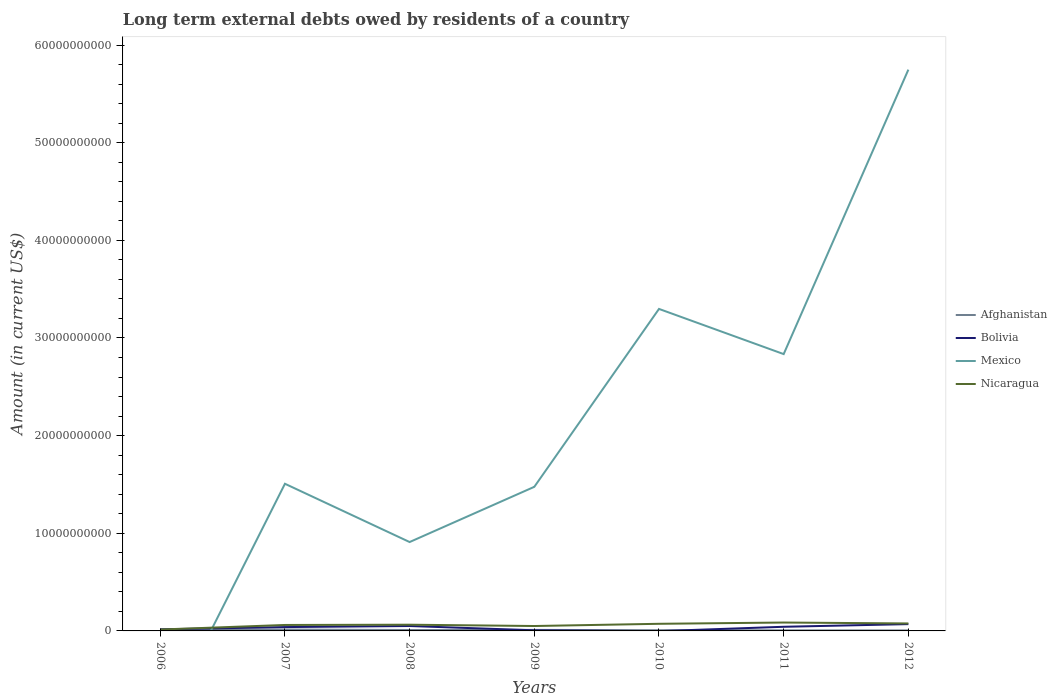Does the line corresponding to Afghanistan intersect with the line corresponding to Bolivia?
Your answer should be compact. Yes. Across all years, what is the maximum amount of long-term external debts owed by residents in Nicaragua?
Provide a short and direct response. 1.42e+08. What is the total amount of long-term external debts owed by residents in Bolivia in the graph?
Make the answer very short. -5.37e+08. What is the difference between the highest and the second highest amount of long-term external debts owed by residents in Nicaragua?
Your answer should be very brief. 7.17e+08. Is the amount of long-term external debts owed by residents in Nicaragua strictly greater than the amount of long-term external debts owed by residents in Mexico over the years?
Keep it short and to the point. No. How many lines are there?
Make the answer very short. 4. Are the values on the major ticks of Y-axis written in scientific E-notation?
Give a very brief answer. No. Does the graph contain grids?
Ensure brevity in your answer.  No. How many legend labels are there?
Provide a short and direct response. 4. What is the title of the graph?
Give a very brief answer. Long term external debts owed by residents of a country. Does "Malaysia" appear as one of the legend labels in the graph?
Your answer should be compact. No. What is the label or title of the Y-axis?
Make the answer very short. Amount (in current US$). What is the Amount (in current US$) of Afghanistan in 2006?
Your answer should be compact. 1.43e+08. What is the Amount (in current US$) of Bolivia in 2006?
Make the answer very short. 1.61e+08. What is the Amount (in current US$) of Nicaragua in 2006?
Give a very brief answer. 1.42e+08. What is the Amount (in current US$) in Afghanistan in 2007?
Keep it short and to the point. 1.46e+08. What is the Amount (in current US$) of Bolivia in 2007?
Ensure brevity in your answer.  3.93e+08. What is the Amount (in current US$) in Mexico in 2007?
Your answer should be compact. 1.51e+1. What is the Amount (in current US$) in Nicaragua in 2007?
Your answer should be compact. 6.09e+08. What is the Amount (in current US$) of Afghanistan in 2008?
Provide a succinct answer. 9.51e+07. What is the Amount (in current US$) in Bolivia in 2008?
Your answer should be very brief. 5.02e+08. What is the Amount (in current US$) of Mexico in 2008?
Provide a succinct answer. 9.10e+09. What is the Amount (in current US$) of Nicaragua in 2008?
Ensure brevity in your answer.  6.36e+08. What is the Amount (in current US$) of Afghanistan in 2009?
Your answer should be very brief. 1.06e+08. What is the Amount (in current US$) in Bolivia in 2009?
Offer a very short reply. 6.47e+07. What is the Amount (in current US$) in Mexico in 2009?
Make the answer very short. 1.48e+1. What is the Amount (in current US$) in Nicaragua in 2009?
Ensure brevity in your answer.  5.03e+08. What is the Amount (in current US$) of Afghanistan in 2010?
Provide a succinct answer. 7.50e+07. What is the Amount (in current US$) in Mexico in 2010?
Your response must be concise. 3.30e+1. What is the Amount (in current US$) in Nicaragua in 2010?
Make the answer very short. 7.29e+08. What is the Amount (in current US$) of Afghanistan in 2011?
Offer a terse response. 6.14e+07. What is the Amount (in current US$) of Bolivia in 2011?
Offer a very short reply. 4.25e+08. What is the Amount (in current US$) in Mexico in 2011?
Offer a terse response. 2.83e+1. What is the Amount (in current US$) in Nicaragua in 2011?
Provide a succinct answer. 8.59e+08. What is the Amount (in current US$) of Afghanistan in 2012?
Ensure brevity in your answer.  5.12e+07. What is the Amount (in current US$) in Bolivia in 2012?
Keep it short and to the point. 6.98e+08. What is the Amount (in current US$) of Mexico in 2012?
Keep it short and to the point. 5.75e+1. What is the Amount (in current US$) of Nicaragua in 2012?
Your answer should be very brief. 7.65e+08. Across all years, what is the maximum Amount (in current US$) in Afghanistan?
Make the answer very short. 1.46e+08. Across all years, what is the maximum Amount (in current US$) in Bolivia?
Keep it short and to the point. 6.98e+08. Across all years, what is the maximum Amount (in current US$) in Mexico?
Provide a short and direct response. 5.75e+1. Across all years, what is the maximum Amount (in current US$) of Nicaragua?
Provide a succinct answer. 8.59e+08. Across all years, what is the minimum Amount (in current US$) in Afghanistan?
Offer a very short reply. 5.12e+07. Across all years, what is the minimum Amount (in current US$) of Bolivia?
Offer a terse response. 0. Across all years, what is the minimum Amount (in current US$) in Nicaragua?
Provide a short and direct response. 1.42e+08. What is the total Amount (in current US$) of Afghanistan in the graph?
Give a very brief answer. 6.77e+08. What is the total Amount (in current US$) of Bolivia in the graph?
Provide a succinct answer. 2.24e+09. What is the total Amount (in current US$) of Mexico in the graph?
Provide a succinct answer. 1.58e+11. What is the total Amount (in current US$) of Nicaragua in the graph?
Your answer should be very brief. 4.24e+09. What is the difference between the Amount (in current US$) in Afghanistan in 2006 and that in 2007?
Provide a succinct answer. -2.77e+06. What is the difference between the Amount (in current US$) of Bolivia in 2006 and that in 2007?
Provide a short and direct response. -2.32e+08. What is the difference between the Amount (in current US$) of Nicaragua in 2006 and that in 2007?
Offer a very short reply. -4.67e+08. What is the difference between the Amount (in current US$) in Afghanistan in 2006 and that in 2008?
Provide a succinct answer. 4.78e+07. What is the difference between the Amount (in current US$) of Bolivia in 2006 and that in 2008?
Your answer should be compact. -3.41e+08. What is the difference between the Amount (in current US$) of Nicaragua in 2006 and that in 2008?
Keep it short and to the point. -4.95e+08. What is the difference between the Amount (in current US$) in Afghanistan in 2006 and that in 2009?
Offer a very short reply. 3.73e+07. What is the difference between the Amount (in current US$) of Bolivia in 2006 and that in 2009?
Provide a succinct answer. 9.64e+07. What is the difference between the Amount (in current US$) in Nicaragua in 2006 and that in 2009?
Your answer should be compact. -3.61e+08. What is the difference between the Amount (in current US$) of Afghanistan in 2006 and that in 2010?
Ensure brevity in your answer.  6.79e+07. What is the difference between the Amount (in current US$) of Nicaragua in 2006 and that in 2010?
Ensure brevity in your answer.  -5.88e+08. What is the difference between the Amount (in current US$) in Afghanistan in 2006 and that in 2011?
Offer a terse response. 8.16e+07. What is the difference between the Amount (in current US$) of Bolivia in 2006 and that in 2011?
Your response must be concise. -2.63e+08. What is the difference between the Amount (in current US$) in Nicaragua in 2006 and that in 2011?
Your answer should be very brief. -7.17e+08. What is the difference between the Amount (in current US$) in Afghanistan in 2006 and that in 2012?
Your answer should be very brief. 9.18e+07. What is the difference between the Amount (in current US$) of Bolivia in 2006 and that in 2012?
Your response must be concise. -5.37e+08. What is the difference between the Amount (in current US$) in Nicaragua in 2006 and that in 2012?
Offer a terse response. -6.23e+08. What is the difference between the Amount (in current US$) in Afghanistan in 2007 and that in 2008?
Offer a terse response. 5.06e+07. What is the difference between the Amount (in current US$) in Bolivia in 2007 and that in 2008?
Provide a succinct answer. -1.09e+08. What is the difference between the Amount (in current US$) of Mexico in 2007 and that in 2008?
Your answer should be very brief. 5.97e+09. What is the difference between the Amount (in current US$) of Nicaragua in 2007 and that in 2008?
Your answer should be compact. -2.75e+07. What is the difference between the Amount (in current US$) in Afghanistan in 2007 and that in 2009?
Provide a succinct answer. 4.01e+07. What is the difference between the Amount (in current US$) in Bolivia in 2007 and that in 2009?
Your answer should be compact. 3.28e+08. What is the difference between the Amount (in current US$) of Mexico in 2007 and that in 2009?
Ensure brevity in your answer.  3.13e+08. What is the difference between the Amount (in current US$) in Nicaragua in 2007 and that in 2009?
Offer a terse response. 1.06e+08. What is the difference between the Amount (in current US$) in Afghanistan in 2007 and that in 2010?
Your answer should be very brief. 7.07e+07. What is the difference between the Amount (in current US$) in Mexico in 2007 and that in 2010?
Give a very brief answer. -1.79e+1. What is the difference between the Amount (in current US$) of Nicaragua in 2007 and that in 2010?
Give a very brief answer. -1.21e+08. What is the difference between the Amount (in current US$) of Afghanistan in 2007 and that in 2011?
Give a very brief answer. 8.43e+07. What is the difference between the Amount (in current US$) of Bolivia in 2007 and that in 2011?
Keep it short and to the point. -3.15e+07. What is the difference between the Amount (in current US$) of Mexico in 2007 and that in 2011?
Your answer should be compact. -1.33e+1. What is the difference between the Amount (in current US$) of Nicaragua in 2007 and that in 2011?
Provide a short and direct response. -2.50e+08. What is the difference between the Amount (in current US$) of Afghanistan in 2007 and that in 2012?
Your answer should be compact. 9.45e+07. What is the difference between the Amount (in current US$) of Bolivia in 2007 and that in 2012?
Offer a very short reply. -3.05e+08. What is the difference between the Amount (in current US$) in Mexico in 2007 and that in 2012?
Give a very brief answer. -4.24e+1. What is the difference between the Amount (in current US$) of Nicaragua in 2007 and that in 2012?
Make the answer very short. -1.56e+08. What is the difference between the Amount (in current US$) in Afghanistan in 2008 and that in 2009?
Ensure brevity in your answer.  -1.05e+07. What is the difference between the Amount (in current US$) in Bolivia in 2008 and that in 2009?
Your answer should be very brief. 4.38e+08. What is the difference between the Amount (in current US$) in Mexico in 2008 and that in 2009?
Your answer should be very brief. -5.65e+09. What is the difference between the Amount (in current US$) in Nicaragua in 2008 and that in 2009?
Provide a short and direct response. 1.34e+08. What is the difference between the Amount (in current US$) in Afghanistan in 2008 and that in 2010?
Keep it short and to the point. 2.01e+07. What is the difference between the Amount (in current US$) of Mexico in 2008 and that in 2010?
Your answer should be compact. -2.39e+1. What is the difference between the Amount (in current US$) of Nicaragua in 2008 and that in 2010?
Give a very brief answer. -9.31e+07. What is the difference between the Amount (in current US$) of Afghanistan in 2008 and that in 2011?
Give a very brief answer. 3.37e+07. What is the difference between the Amount (in current US$) in Bolivia in 2008 and that in 2011?
Your response must be concise. 7.78e+07. What is the difference between the Amount (in current US$) of Mexico in 2008 and that in 2011?
Your answer should be compact. -1.92e+1. What is the difference between the Amount (in current US$) in Nicaragua in 2008 and that in 2011?
Keep it short and to the point. -2.22e+08. What is the difference between the Amount (in current US$) in Afghanistan in 2008 and that in 2012?
Your answer should be compact. 4.39e+07. What is the difference between the Amount (in current US$) of Bolivia in 2008 and that in 2012?
Provide a short and direct response. -1.96e+08. What is the difference between the Amount (in current US$) in Mexico in 2008 and that in 2012?
Make the answer very short. -4.84e+1. What is the difference between the Amount (in current US$) in Nicaragua in 2008 and that in 2012?
Your response must be concise. -1.29e+08. What is the difference between the Amount (in current US$) in Afghanistan in 2009 and that in 2010?
Your response must be concise. 3.06e+07. What is the difference between the Amount (in current US$) of Mexico in 2009 and that in 2010?
Ensure brevity in your answer.  -1.82e+1. What is the difference between the Amount (in current US$) in Nicaragua in 2009 and that in 2010?
Keep it short and to the point. -2.27e+08. What is the difference between the Amount (in current US$) in Afghanistan in 2009 and that in 2011?
Give a very brief answer. 4.43e+07. What is the difference between the Amount (in current US$) of Bolivia in 2009 and that in 2011?
Keep it short and to the point. -3.60e+08. What is the difference between the Amount (in current US$) in Mexico in 2009 and that in 2011?
Make the answer very short. -1.36e+1. What is the difference between the Amount (in current US$) in Nicaragua in 2009 and that in 2011?
Ensure brevity in your answer.  -3.56e+08. What is the difference between the Amount (in current US$) of Afghanistan in 2009 and that in 2012?
Provide a short and direct response. 5.45e+07. What is the difference between the Amount (in current US$) in Bolivia in 2009 and that in 2012?
Your answer should be very brief. -6.34e+08. What is the difference between the Amount (in current US$) in Mexico in 2009 and that in 2012?
Offer a very short reply. -4.27e+1. What is the difference between the Amount (in current US$) of Nicaragua in 2009 and that in 2012?
Provide a succinct answer. -2.62e+08. What is the difference between the Amount (in current US$) of Afghanistan in 2010 and that in 2011?
Provide a short and direct response. 1.37e+07. What is the difference between the Amount (in current US$) in Mexico in 2010 and that in 2011?
Give a very brief answer. 4.63e+09. What is the difference between the Amount (in current US$) of Nicaragua in 2010 and that in 2011?
Provide a short and direct response. -1.29e+08. What is the difference between the Amount (in current US$) in Afghanistan in 2010 and that in 2012?
Provide a succinct answer. 2.39e+07. What is the difference between the Amount (in current US$) in Mexico in 2010 and that in 2012?
Give a very brief answer. -2.45e+1. What is the difference between the Amount (in current US$) in Nicaragua in 2010 and that in 2012?
Your answer should be very brief. -3.56e+07. What is the difference between the Amount (in current US$) in Afghanistan in 2011 and that in 2012?
Make the answer very short. 1.02e+07. What is the difference between the Amount (in current US$) in Bolivia in 2011 and that in 2012?
Ensure brevity in your answer.  -2.74e+08. What is the difference between the Amount (in current US$) in Mexico in 2011 and that in 2012?
Your answer should be compact. -2.91e+1. What is the difference between the Amount (in current US$) in Nicaragua in 2011 and that in 2012?
Your answer should be very brief. 9.35e+07. What is the difference between the Amount (in current US$) of Afghanistan in 2006 and the Amount (in current US$) of Bolivia in 2007?
Make the answer very short. -2.50e+08. What is the difference between the Amount (in current US$) in Afghanistan in 2006 and the Amount (in current US$) in Mexico in 2007?
Your answer should be compact. -1.49e+1. What is the difference between the Amount (in current US$) in Afghanistan in 2006 and the Amount (in current US$) in Nicaragua in 2007?
Your answer should be very brief. -4.66e+08. What is the difference between the Amount (in current US$) in Bolivia in 2006 and the Amount (in current US$) in Mexico in 2007?
Give a very brief answer. -1.49e+1. What is the difference between the Amount (in current US$) in Bolivia in 2006 and the Amount (in current US$) in Nicaragua in 2007?
Offer a very short reply. -4.48e+08. What is the difference between the Amount (in current US$) in Afghanistan in 2006 and the Amount (in current US$) in Bolivia in 2008?
Your answer should be compact. -3.59e+08. What is the difference between the Amount (in current US$) of Afghanistan in 2006 and the Amount (in current US$) of Mexico in 2008?
Give a very brief answer. -8.96e+09. What is the difference between the Amount (in current US$) of Afghanistan in 2006 and the Amount (in current US$) of Nicaragua in 2008?
Provide a short and direct response. -4.93e+08. What is the difference between the Amount (in current US$) in Bolivia in 2006 and the Amount (in current US$) in Mexico in 2008?
Provide a succinct answer. -8.94e+09. What is the difference between the Amount (in current US$) of Bolivia in 2006 and the Amount (in current US$) of Nicaragua in 2008?
Your answer should be very brief. -4.75e+08. What is the difference between the Amount (in current US$) of Afghanistan in 2006 and the Amount (in current US$) of Bolivia in 2009?
Make the answer very short. 7.83e+07. What is the difference between the Amount (in current US$) in Afghanistan in 2006 and the Amount (in current US$) in Mexico in 2009?
Give a very brief answer. -1.46e+1. What is the difference between the Amount (in current US$) of Afghanistan in 2006 and the Amount (in current US$) of Nicaragua in 2009?
Give a very brief answer. -3.60e+08. What is the difference between the Amount (in current US$) in Bolivia in 2006 and the Amount (in current US$) in Mexico in 2009?
Your answer should be compact. -1.46e+1. What is the difference between the Amount (in current US$) in Bolivia in 2006 and the Amount (in current US$) in Nicaragua in 2009?
Give a very brief answer. -3.42e+08. What is the difference between the Amount (in current US$) of Afghanistan in 2006 and the Amount (in current US$) of Mexico in 2010?
Your answer should be very brief. -3.28e+1. What is the difference between the Amount (in current US$) in Afghanistan in 2006 and the Amount (in current US$) in Nicaragua in 2010?
Your answer should be very brief. -5.86e+08. What is the difference between the Amount (in current US$) of Bolivia in 2006 and the Amount (in current US$) of Mexico in 2010?
Keep it short and to the point. -3.28e+1. What is the difference between the Amount (in current US$) in Bolivia in 2006 and the Amount (in current US$) in Nicaragua in 2010?
Give a very brief answer. -5.68e+08. What is the difference between the Amount (in current US$) of Afghanistan in 2006 and the Amount (in current US$) of Bolivia in 2011?
Your answer should be compact. -2.82e+08. What is the difference between the Amount (in current US$) in Afghanistan in 2006 and the Amount (in current US$) in Mexico in 2011?
Give a very brief answer. -2.82e+1. What is the difference between the Amount (in current US$) in Afghanistan in 2006 and the Amount (in current US$) in Nicaragua in 2011?
Your response must be concise. -7.16e+08. What is the difference between the Amount (in current US$) of Bolivia in 2006 and the Amount (in current US$) of Mexico in 2011?
Your response must be concise. -2.82e+1. What is the difference between the Amount (in current US$) of Bolivia in 2006 and the Amount (in current US$) of Nicaragua in 2011?
Provide a succinct answer. -6.97e+08. What is the difference between the Amount (in current US$) of Afghanistan in 2006 and the Amount (in current US$) of Bolivia in 2012?
Your answer should be very brief. -5.55e+08. What is the difference between the Amount (in current US$) in Afghanistan in 2006 and the Amount (in current US$) in Mexico in 2012?
Make the answer very short. -5.73e+1. What is the difference between the Amount (in current US$) of Afghanistan in 2006 and the Amount (in current US$) of Nicaragua in 2012?
Provide a short and direct response. -6.22e+08. What is the difference between the Amount (in current US$) of Bolivia in 2006 and the Amount (in current US$) of Mexico in 2012?
Make the answer very short. -5.73e+1. What is the difference between the Amount (in current US$) in Bolivia in 2006 and the Amount (in current US$) in Nicaragua in 2012?
Provide a succinct answer. -6.04e+08. What is the difference between the Amount (in current US$) of Afghanistan in 2007 and the Amount (in current US$) of Bolivia in 2008?
Provide a short and direct response. -3.57e+08. What is the difference between the Amount (in current US$) in Afghanistan in 2007 and the Amount (in current US$) in Mexico in 2008?
Your response must be concise. -8.96e+09. What is the difference between the Amount (in current US$) of Afghanistan in 2007 and the Amount (in current US$) of Nicaragua in 2008?
Make the answer very short. -4.91e+08. What is the difference between the Amount (in current US$) in Bolivia in 2007 and the Amount (in current US$) in Mexico in 2008?
Offer a very short reply. -8.71e+09. What is the difference between the Amount (in current US$) in Bolivia in 2007 and the Amount (in current US$) in Nicaragua in 2008?
Offer a terse response. -2.43e+08. What is the difference between the Amount (in current US$) of Mexico in 2007 and the Amount (in current US$) of Nicaragua in 2008?
Give a very brief answer. 1.44e+1. What is the difference between the Amount (in current US$) in Afghanistan in 2007 and the Amount (in current US$) in Bolivia in 2009?
Give a very brief answer. 8.10e+07. What is the difference between the Amount (in current US$) of Afghanistan in 2007 and the Amount (in current US$) of Mexico in 2009?
Offer a very short reply. -1.46e+1. What is the difference between the Amount (in current US$) in Afghanistan in 2007 and the Amount (in current US$) in Nicaragua in 2009?
Make the answer very short. -3.57e+08. What is the difference between the Amount (in current US$) of Bolivia in 2007 and the Amount (in current US$) of Mexico in 2009?
Provide a succinct answer. -1.44e+1. What is the difference between the Amount (in current US$) in Bolivia in 2007 and the Amount (in current US$) in Nicaragua in 2009?
Your response must be concise. -1.10e+08. What is the difference between the Amount (in current US$) in Mexico in 2007 and the Amount (in current US$) in Nicaragua in 2009?
Make the answer very short. 1.46e+1. What is the difference between the Amount (in current US$) of Afghanistan in 2007 and the Amount (in current US$) of Mexico in 2010?
Keep it short and to the point. -3.28e+1. What is the difference between the Amount (in current US$) of Afghanistan in 2007 and the Amount (in current US$) of Nicaragua in 2010?
Offer a terse response. -5.84e+08. What is the difference between the Amount (in current US$) in Bolivia in 2007 and the Amount (in current US$) in Mexico in 2010?
Offer a terse response. -3.26e+1. What is the difference between the Amount (in current US$) in Bolivia in 2007 and the Amount (in current US$) in Nicaragua in 2010?
Provide a succinct answer. -3.36e+08. What is the difference between the Amount (in current US$) in Mexico in 2007 and the Amount (in current US$) in Nicaragua in 2010?
Your answer should be compact. 1.43e+1. What is the difference between the Amount (in current US$) in Afghanistan in 2007 and the Amount (in current US$) in Bolivia in 2011?
Your response must be concise. -2.79e+08. What is the difference between the Amount (in current US$) of Afghanistan in 2007 and the Amount (in current US$) of Mexico in 2011?
Keep it short and to the point. -2.82e+1. What is the difference between the Amount (in current US$) of Afghanistan in 2007 and the Amount (in current US$) of Nicaragua in 2011?
Your answer should be very brief. -7.13e+08. What is the difference between the Amount (in current US$) of Bolivia in 2007 and the Amount (in current US$) of Mexico in 2011?
Provide a short and direct response. -2.80e+1. What is the difference between the Amount (in current US$) of Bolivia in 2007 and the Amount (in current US$) of Nicaragua in 2011?
Keep it short and to the point. -4.66e+08. What is the difference between the Amount (in current US$) of Mexico in 2007 and the Amount (in current US$) of Nicaragua in 2011?
Provide a succinct answer. 1.42e+1. What is the difference between the Amount (in current US$) of Afghanistan in 2007 and the Amount (in current US$) of Bolivia in 2012?
Make the answer very short. -5.52e+08. What is the difference between the Amount (in current US$) of Afghanistan in 2007 and the Amount (in current US$) of Mexico in 2012?
Offer a very short reply. -5.73e+1. What is the difference between the Amount (in current US$) of Afghanistan in 2007 and the Amount (in current US$) of Nicaragua in 2012?
Make the answer very short. -6.19e+08. What is the difference between the Amount (in current US$) in Bolivia in 2007 and the Amount (in current US$) in Mexico in 2012?
Make the answer very short. -5.71e+1. What is the difference between the Amount (in current US$) of Bolivia in 2007 and the Amount (in current US$) of Nicaragua in 2012?
Keep it short and to the point. -3.72e+08. What is the difference between the Amount (in current US$) in Mexico in 2007 and the Amount (in current US$) in Nicaragua in 2012?
Keep it short and to the point. 1.43e+1. What is the difference between the Amount (in current US$) of Afghanistan in 2008 and the Amount (in current US$) of Bolivia in 2009?
Keep it short and to the point. 3.04e+07. What is the difference between the Amount (in current US$) in Afghanistan in 2008 and the Amount (in current US$) in Mexico in 2009?
Ensure brevity in your answer.  -1.47e+1. What is the difference between the Amount (in current US$) in Afghanistan in 2008 and the Amount (in current US$) in Nicaragua in 2009?
Make the answer very short. -4.08e+08. What is the difference between the Amount (in current US$) of Bolivia in 2008 and the Amount (in current US$) of Mexico in 2009?
Make the answer very short. -1.43e+1. What is the difference between the Amount (in current US$) of Bolivia in 2008 and the Amount (in current US$) of Nicaragua in 2009?
Your answer should be compact. -4.03e+05. What is the difference between the Amount (in current US$) of Mexico in 2008 and the Amount (in current US$) of Nicaragua in 2009?
Give a very brief answer. 8.60e+09. What is the difference between the Amount (in current US$) of Afghanistan in 2008 and the Amount (in current US$) of Mexico in 2010?
Your response must be concise. -3.29e+1. What is the difference between the Amount (in current US$) of Afghanistan in 2008 and the Amount (in current US$) of Nicaragua in 2010?
Offer a terse response. -6.34e+08. What is the difference between the Amount (in current US$) in Bolivia in 2008 and the Amount (in current US$) in Mexico in 2010?
Make the answer very short. -3.25e+1. What is the difference between the Amount (in current US$) of Bolivia in 2008 and the Amount (in current US$) of Nicaragua in 2010?
Ensure brevity in your answer.  -2.27e+08. What is the difference between the Amount (in current US$) in Mexico in 2008 and the Amount (in current US$) in Nicaragua in 2010?
Your answer should be compact. 8.37e+09. What is the difference between the Amount (in current US$) in Afghanistan in 2008 and the Amount (in current US$) in Bolivia in 2011?
Give a very brief answer. -3.29e+08. What is the difference between the Amount (in current US$) in Afghanistan in 2008 and the Amount (in current US$) in Mexico in 2011?
Your answer should be very brief. -2.83e+1. What is the difference between the Amount (in current US$) in Afghanistan in 2008 and the Amount (in current US$) in Nicaragua in 2011?
Your answer should be very brief. -7.63e+08. What is the difference between the Amount (in current US$) in Bolivia in 2008 and the Amount (in current US$) in Mexico in 2011?
Ensure brevity in your answer.  -2.78e+1. What is the difference between the Amount (in current US$) of Bolivia in 2008 and the Amount (in current US$) of Nicaragua in 2011?
Keep it short and to the point. -3.56e+08. What is the difference between the Amount (in current US$) of Mexico in 2008 and the Amount (in current US$) of Nicaragua in 2011?
Your answer should be very brief. 8.24e+09. What is the difference between the Amount (in current US$) in Afghanistan in 2008 and the Amount (in current US$) in Bolivia in 2012?
Make the answer very short. -6.03e+08. What is the difference between the Amount (in current US$) in Afghanistan in 2008 and the Amount (in current US$) in Mexico in 2012?
Make the answer very short. -5.74e+1. What is the difference between the Amount (in current US$) of Afghanistan in 2008 and the Amount (in current US$) of Nicaragua in 2012?
Offer a terse response. -6.70e+08. What is the difference between the Amount (in current US$) in Bolivia in 2008 and the Amount (in current US$) in Mexico in 2012?
Give a very brief answer. -5.70e+1. What is the difference between the Amount (in current US$) of Bolivia in 2008 and the Amount (in current US$) of Nicaragua in 2012?
Your answer should be compact. -2.63e+08. What is the difference between the Amount (in current US$) of Mexico in 2008 and the Amount (in current US$) of Nicaragua in 2012?
Offer a very short reply. 8.34e+09. What is the difference between the Amount (in current US$) in Afghanistan in 2009 and the Amount (in current US$) in Mexico in 2010?
Ensure brevity in your answer.  -3.29e+1. What is the difference between the Amount (in current US$) of Afghanistan in 2009 and the Amount (in current US$) of Nicaragua in 2010?
Provide a succinct answer. -6.24e+08. What is the difference between the Amount (in current US$) in Bolivia in 2009 and the Amount (in current US$) in Mexico in 2010?
Make the answer very short. -3.29e+1. What is the difference between the Amount (in current US$) in Bolivia in 2009 and the Amount (in current US$) in Nicaragua in 2010?
Ensure brevity in your answer.  -6.65e+08. What is the difference between the Amount (in current US$) of Mexico in 2009 and the Amount (in current US$) of Nicaragua in 2010?
Keep it short and to the point. 1.40e+1. What is the difference between the Amount (in current US$) of Afghanistan in 2009 and the Amount (in current US$) of Bolivia in 2011?
Offer a very short reply. -3.19e+08. What is the difference between the Amount (in current US$) of Afghanistan in 2009 and the Amount (in current US$) of Mexico in 2011?
Provide a succinct answer. -2.82e+1. What is the difference between the Amount (in current US$) in Afghanistan in 2009 and the Amount (in current US$) in Nicaragua in 2011?
Your response must be concise. -7.53e+08. What is the difference between the Amount (in current US$) of Bolivia in 2009 and the Amount (in current US$) of Mexico in 2011?
Your response must be concise. -2.83e+1. What is the difference between the Amount (in current US$) of Bolivia in 2009 and the Amount (in current US$) of Nicaragua in 2011?
Provide a succinct answer. -7.94e+08. What is the difference between the Amount (in current US$) in Mexico in 2009 and the Amount (in current US$) in Nicaragua in 2011?
Your answer should be compact. 1.39e+1. What is the difference between the Amount (in current US$) of Afghanistan in 2009 and the Amount (in current US$) of Bolivia in 2012?
Provide a short and direct response. -5.93e+08. What is the difference between the Amount (in current US$) in Afghanistan in 2009 and the Amount (in current US$) in Mexico in 2012?
Make the answer very short. -5.74e+1. What is the difference between the Amount (in current US$) of Afghanistan in 2009 and the Amount (in current US$) of Nicaragua in 2012?
Your answer should be very brief. -6.59e+08. What is the difference between the Amount (in current US$) of Bolivia in 2009 and the Amount (in current US$) of Mexico in 2012?
Your response must be concise. -5.74e+1. What is the difference between the Amount (in current US$) of Bolivia in 2009 and the Amount (in current US$) of Nicaragua in 2012?
Offer a very short reply. -7.00e+08. What is the difference between the Amount (in current US$) in Mexico in 2009 and the Amount (in current US$) in Nicaragua in 2012?
Give a very brief answer. 1.40e+1. What is the difference between the Amount (in current US$) of Afghanistan in 2010 and the Amount (in current US$) of Bolivia in 2011?
Offer a very short reply. -3.50e+08. What is the difference between the Amount (in current US$) of Afghanistan in 2010 and the Amount (in current US$) of Mexico in 2011?
Your answer should be very brief. -2.83e+1. What is the difference between the Amount (in current US$) in Afghanistan in 2010 and the Amount (in current US$) in Nicaragua in 2011?
Your answer should be compact. -7.84e+08. What is the difference between the Amount (in current US$) in Mexico in 2010 and the Amount (in current US$) in Nicaragua in 2011?
Make the answer very short. 3.21e+1. What is the difference between the Amount (in current US$) of Afghanistan in 2010 and the Amount (in current US$) of Bolivia in 2012?
Your answer should be very brief. -6.23e+08. What is the difference between the Amount (in current US$) of Afghanistan in 2010 and the Amount (in current US$) of Mexico in 2012?
Provide a succinct answer. -5.74e+1. What is the difference between the Amount (in current US$) of Afghanistan in 2010 and the Amount (in current US$) of Nicaragua in 2012?
Give a very brief answer. -6.90e+08. What is the difference between the Amount (in current US$) of Mexico in 2010 and the Amount (in current US$) of Nicaragua in 2012?
Your answer should be very brief. 3.22e+1. What is the difference between the Amount (in current US$) in Afghanistan in 2011 and the Amount (in current US$) in Bolivia in 2012?
Your response must be concise. -6.37e+08. What is the difference between the Amount (in current US$) in Afghanistan in 2011 and the Amount (in current US$) in Mexico in 2012?
Offer a very short reply. -5.74e+1. What is the difference between the Amount (in current US$) in Afghanistan in 2011 and the Amount (in current US$) in Nicaragua in 2012?
Your answer should be very brief. -7.04e+08. What is the difference between the Amount (in current US$) in Bolivia in 2011 and the Amount (in current US$) in Mexico in 2012?
Ensure brevity in your answer.  -5.71e+1. What is the difference between the Amount (in current US$) in Bolivia in 2011 and the Amount (in current US$) in Nicaragua in 2012?
Keep it short and to the point. -3.41e+08. What is the difference between the Amount (in current US$) in Mexico in 2011 and the Amount (in current US$) in Nicaragua in 2012?
Ensure brevity in your answer.  2.76e+1. What is the average Amount (in current US$) of Afghanistan per year?
Your answer should be compact. 9.67e+07. What is the average Amount (in current US$) of Bolivia per year?
Your response must be concise. 3.21e+08. What is the average Amount (in current US$) of Mexico per year?
Ensure brevity in your answer.  2.25e+1. What is the average Amount (in current US$) in Nicaragua per year?
Give a very brief answer. 6.06e+08. In the year 2006, what is the difference between the Amount (in current US$) in Afghanistan and Amount (in current US$) in Bolivia?
Give a very brief answer. -1.82e+07. In the year 2006, what is the difference between the Amount (in current US$) in Afghanistan and Amount (in current US$) in Nicaragua?
Keep it short and to the point. 1.22e+06. In the year 2006, what is the difference between the Amount (in current US$) of Bolivia and Amount (in current US$) of Nicaragua?
Your answer should be very brief. 1.94e+07. In the year 2007, what is the difference between the Amount (in current US$) of Afghanistan and Amount (in current US$) of Bolivia?
Offer a terse response. -2.47e+08. In the year 2007, what is the difference between the Amount (in current US$) of Afghanistan and Amount (in current US$) of Mexico?
Make the answer very short. -1.49e+1. In the year 2007, what is the difference between the Amount (in current US$) in Afghanistan and Amount (in current US$) in Nicaragua?
Offer a terse response. -4.63e+08. In the year 2007, what is the difference between the Amount (in current US$) of Bolivia and Amount (in current US$) of Mexico?
Provide a succinct answer. -1.47e+1. In the year 2007, what is the difference between the Amount (in current US$) in Bolivia and Amount (in current US$) in Nicaragua?
Offer a very short reply. -2.16e+08. In the year 2007, what is the difference between the Amount (in current US$) of Mexico and Amount (in current US$) of Nicaragua?
Provide a succinct answer. 1.45e+1. In the year 2008, what is the difference between the Amount (in current US$) in Afghanistan and Amount (in current US$) in Bolivia?
Your answer should be very brief. -4.07e+08. In the year 2008, what is the difference between the Amount (in current US$) of Afghanistan and Amount (in current US$) of Mexico?
Make the answer very short. -9.01e+09. In the year 2008, what is the difference between the Amount (in current US$) of Afghanistan and Amount (in current US$) of Nicaragua?
Offer a terse response. -5.41e+08. In the year 2008, what is the difference between the Amount (in current US$) of Bolivia and Amount (in current US$) of Mexico?
Ensure brevity in your answer.  -8.60e+09. In the year 2008, what is the difference between the Amount (in current US$) in Bolivia and Amount (in current US$) in Nicaragua?
Your answer should be compact. -1.34e+08. In the year 2008, what is the difference between the Amount (in current US$) in Mexico and Amount (in current US$) in Nicaragua?
Provide a succinct answer. 8.47e+09. In the year 2009, what is the difference between the Amount (in current US$) in Afghanistan and Amount (in current US$) in Bolivia?
Provide a succinct answer. 4.10e+07. In the year 2009, what is the difference between the Amount (in current US$) of Afghanistan and Amount (in current US$) of Mexico?
Keep it short and to the point. -1.47e+1. In the year 2009, what is the difference between the Amount (in current US$) of Afghanistan and Amount (in current US$) of Nicaragua?
Keep it short and to the point. -3.97e+08. In the year 2009, what is the difference between the Amount (in current US$) of Bolivia and Amount (in current US$) of Mexico?
Keep it short and to the point. -1.47e+1. In the year 2009, what is the difference between the Amount (in current US$) of Bolivia and Amount (in current US$) of Nicaragua?
Provide a short and direct response. -4.38e+08. In the year 2009, what is the difference between the Amount (in current US$) of Mexico and Amount (in current US$) of Nicaragua?
Provide a short and direct response. 1.43e+1. In the year 2010, what is the difference between the Amount (in current US$) of Afghanistan and Amount (in current US$) of Mexico?
Provide a short and direct response. -3.29e+1. In the year 2010, what is the difference between the Amount (in current US$) of Afghanistan and Amount (in current US$) of Nicaragua?
Make the answer very short. -6.54e+08. In the year 2010, what is the difference between the Amount (in current US$) in Mexico and Amount (in current US$) in Nicaragua?
Ensure brevity in your answer.  3.22e+1. In the year 2011, what is the difference between the Amount (in current US$) in Afghanistan and Amount (in current US$) in Bolivia?
Give a very brief answer. -3.63e+08. In the year 2011, what is the difference between the Amount (in current US$) in Afghanistan and Amount (in current US$) in Mexico?
Your answer should be very brief. -2.83e+1. In the year 2011, what is the difference between the Amount (in current US$) in Afghanistan and Amount (in current US$) in Nicaragua?
Ensure brevity in your answer.  -7.97e+08. In the year 2011, what is the difference between the Amount (in current US$) of Bolivia and Amount (in current US$) of Mexico?
Offer a very short reply. -2.79e+1. In the year 2011, what is the difference between the Amount (in current US$) of Bolivia and Amount (in current US$) of Nicaragua?
Offer a very short reply. -4.34e+08. In the year 2011, what is the difference between the Amount (in current US$) in Mexico and Amount (in current US$) in Nicaragua?
Offer a terse response. 2.75e+1. In the year 2012, what is the difference between the Amount (in current US$) in Afghanistan and Amount (in current US$) in Bolivia?
Make the answer very short. -6.47e+08. In the year 2012, what is the difference between the Amount (in current US$) in Afghanistan and Amount (in current US$) in Mexico?
Keep it short and to the point. -5.74e+1. In the year 2012, what is the difference between the Amount (in current US$) of Afghanistan and Amount (in current US$) of Nicaragua?
Give a very brief answer. -7.14e+08. In the year 2012, what is the difference between the Amount (in current US$) in Bolivia and Amount (in current US$) in Mexico?
Provide a short and direct response. -5.68e+1. In the year 2012, what is the difference between the Amount (in current US$) of Bolivia and Amount (in current US$) of Nicaragua?
Offer a terse response. -6.69e+07. In the year 2012, what is the difference between the Amount (in current US$) of Mexico and Amount (in current US$) of Nicaragua?
Provide a short and direct response. 5.67e+1. What is the ratio of the Amount (in current US$) in Bolivia in 2006 to that in 2007?
Offer a terse response. 0.41. What is the ratio of the Amount (in current US$) in Nicaragua in 2006 to that in 2007?
Ensure brevity in your answer.  0.23. What is the ratio of the Amount (in current US$) in Afghanistan in 2006 to that in 2008?
Provide a short and direct response. 1.5. What is the ratio of the Amount (in current US$) in Bolivia in 2006 to that in 2008?
Make the answer very short. 0.32. What is the ratio of the Amount (in current US$) of Nicaragua in 2006 to that in 2008?
Give a very brief answer. 0.22. What is the ratio of the Amount (in current US$) of Afghanistan in 2006 to that in 2009?
Ensure brevity in your answer.  1.35. What is the ratio of the Amount (in current US$) of Bolivia in 2006 to that in 2009?
Your response must be concise. 2.49. What is the ratio of the Amount (in current US$) in Nicaragua in 2006 to that in 2009?
Your response must be concise. 0.28. What is the ratio of the Amount (in current US$) of Afghanistan in 2006 to that in 2010?
Ensure brevity in your answer.  1.91. What is the ratio of the Amount (in current US$) in Nicaragua in 2006 to that in 2010?
Provide a short and direct response. 0.19. What is the ratio of the Amount (in current US$) in Afghanistan in 2006 to that in 2011?
Offer a very short reply. 2.33. What is the ratio of the Amount (in current US$) of Bolivia in 2006 to that in 2011?
Ensure brevity in your answer.  0.38. What is the ratio of the Amount (in current US$) of Nicaragua in 2006 to that in 2011?
Keep it short and to the point. 0.17. What is the ratio of the Amount (in current US$) of Afghanistan in 2006 to that in 2012?
Provide a short and direct response. 2.79. What is the ratio of the Amount (in current US$) of Bolivia in 2006 to that in 2012?
Offer a terse response. 0.23. What is the ratio of the Amount (in current US$) in Nicaragua in 2006 to that in 2012?
Give a very brief answer. 0.19. What is the ratio of the Amount (in current US$) of Afghanistan in 2007 to that in 2008?
Your answer should be compact. 1.53. What is the ratio of the Amount (in current US$) in Bolivia in 2007 to that in 2008?
Your response must be concise. 0.78. What is the ratio of the Amount (in current US$) in Mexico in 2007 to that in 2008?
Your answer should be very brief. 1.66. What is the ratio of the Amount (in current US$) of Nicaragua in 2007 to that in 2008?
Ensure brevity in your answer.  0.96. What is the ratio of the Amount (in current US$) in Afghanistan in 2007 to that in 2009?
Provide a succinct answer. 1.38. What is the ratio of the Amount (in current US$) in Bolivia in 2007 to that in 2009?
Your response must be concise. 6.08. What is the ratio of the Amount (in current US$) in Mexico in 2007 to that in 2009?
Keep it short and to the point. 1.02. What is the ratio of the Amount (in current US$) in Nicaragua in 2007 to that in 2009?
Offer a very short reply. 1.21. What is the ratio of the Amount (in current US$) of Afghanistan in 2007 to that in 2010?
Your response must be concise. 1.94. What is the ratio of the Amount (in current US$) of Mexico in 2007 to that in 2010?
Give a very brief answer. 0.46. What is the ratio of the Amount (in current US$) in Nicaragua in 2007 to that in 2010?
Give a very brief answer. 0.83. What is the ratio of the Amount (in current US$) of Afghanistan in 2007 to that in 2011?
Provide a short and direct response. 2.37. What is the ratio of the Amount (in current US$) of Bolivia in 2007 to that in 2011?
Keep it short and to the point. 0.93. What is the ratio of the Amount (in current US$) in Mexico in 2007 to that in 2011?
Offer a very short reply. 0.53. What is the ratio of the Amount (in current US$) of Nicaragua in 2007 to that in 2011?
Your answer should be compact. 0.71. What is the ratio of the Amount (in current US$) of Afghanistan in 2007 to that in 2012?
Your answer should be compact. 2.85. What is the ratio of the Amount (in current US$) in Bolivia in 2007 to that in 2012?
Offer a very short reply. 0.56. What is the ratio of the Amount (in current US$) of Mexico in 2007 to that in 2012?
Provide a succinct answer. 0.26. What is the ratio of the Amount (in current US$) in Nicaragua in 2007 to that in 2012?
Make the answer very short. 0.8. What is the ratio of the Amount (in current US$) of Afghanistan in 2008 to that in 2009?
Ensure brevity in your answer.  0.9. What is the ratio of the Amount (in current US$) of Bolivia in 2008 to that in 2009?
Keep it short and to the point. 7.77. What is the ratio of the Amount (in current US$) in Mexico in 2008 to that in 2009?
Keep it short and to the point. 0.62. What is the ratio of the Amount (in current US$) of Nicaragua in 2008 to that in 2009?
Your answer should be compact. 1.27. What is the ratio of the Amount (in current US$) of Afghanistan in 2008 to that in 2010?
Your answer should be very brief. 1.27. What is the ratio of the Amount (in current US$) of Mexico in 2008 to that in 2010?
Offer a terse response. 0.28. What is the ratio of the Amount (in current US$) of Nicaragua in 2008 to that in 2010?
Offer a very short reply. 0.87. What is the ratio of the Amount (in current US$) of Afghanistan in 2008 to that in 2011?
Give a very brief answer. 1.55. What is the ratio of the Amount (in current US$) of Bolivia in 2008 to that in 2011?
Offer a very short reply. 1.18. What is the ratio of the Amount (in current US$) in Mexico in 2008 to that in 2011?
Make the answer very short. 0.32. What is the ratio of the Amount (in current US$) of Nicaragua in 2008 to that in 2011?
Give a very brief answer. 0.74. What is the ratio of the Amount (in current US$) in Afghanistan in 2008 to that in 2012?
Ensure brevity in your answer.  1.86. What is the ratio of the Amount (in current US$) of Bolivia in 2008 to that in 2012?
Offer a very short reply. 0.72. What is the ratio of the Amount (in current US$) of Mexico in 2008 to that in 2012?
Give a very brief answer. 0.16. What is the ratio of the Amount (in current US$) of Nicaragua in 2008 to that in 2012?
Your answer should be very brief. 0.83. What is the ratio of the Amount (in current US$) of Afghanistan in 2009 to that in 2010?
Provide a succinct answer. 1.41. What is the ratio of the Amount (in current US$) of Mexico in 2009 to that in 2010?
Provide a short and direct response. 0.45. What is the ratio of the Amount (in current US$) in Nicaragua in 2009 to that in 2010?
Your answer should be very brief. 0.69. What is the ratio of the Amount (in current US$) in Afghanistan in 2009 to that in 2011?
Ensure brevity in your answer.  1.72. What is the ratio of the Amount (in current US$) in Bolivia in 2009 to that in 2011?
Keep it short and to the point. 0.15. What is the ratio of the Amount (in current US$) of Mexico in 2009 to that in 2011?
Give a very brief answer. 0.52. What is the ratio of the Amount (in current US$) in Nicaragua in 2009 to that in 2011?
Your answer should be compact. 0.59. What is the ratio of the Amount (in current US$) of Afghanistan in 2009 to that in 2012?
Offer a very short reply. 2.06. What is the ratio of the Amount (in current US$) of Bolivia in 2009 to that in 2012?
Provide a succinct answer. 0.09. What is the ratio of the Amount (in current US$) in Mexico in 2009 to that in 2012?
Give a very brief answer. 0.26. What is the ratio of the Amount (in current US$) in Nicaragua in 2009 to that in 2012?
Keep it short and to the point. 0.66. What is the ratio of the Amount (in current US$) in Afghanistan in 2010 to that in 2011?
Offer a very short reply. 1.22. What is the ratio of the Amount (in current US$) of Mexico in 2010 to that in 2011?
Your answer should be compact. 1.16. What is the ratio of the Amount (in current US$) in Nicaragua in 2010 to that in 2011?
Provide a short and direct response. 0.85. What is the ratio of the Amount (in current US$) in Afghanistan in 2010 to that in 2012?
Offer a terse response. 1.47. What is the ratio of the Amount (in current US$) in Mexico in 2010 to that in 2012?
Offer a very short reply. 0.57. What is the ratio of the Amount (in current US$) in Nicaragua in 2010 to that in 2012?
Ensure brevity in your answer.  0.95. What is the ratio of the Amount (in current US$) in Afghanistan in 2011 to that in 2012?
Make the answer very short. 1.2. What is the ratio of the Amount (in current US$) in Bolivia in 2011 to that in 2012?
Keep it short and to the point. 0.61. What is the ratio of the Amount (in current US$) in Mexico in 2011 to that in 2012?
Offer a very short reply. 0.49. What is the ratio of the Amount (in current US$) in Nicaragua in 2011 to that in 2012?
Keep it short and to the point. 1.12. What is the difference between the highest and the second highest Amount (in current US$) in Afghanistan?
Your response must be concise. 2.77e+06. What is the difference between the highest and the second highest Amount (in current US$) in Bolivia?
Your response must be concise. 1.96e+08. What is the difference between the highest and the second highest Amount (in current US$) of Mexico?
Offer a very short reply. 2.45e+1. What is the difference between the highest and the second highest Amount (in current US$) of Nicaragua?
Offer a terse response. 9.35e+07. What is the difference between the highest and the lowest Amount (in current US$) in Afghanistan?
Provide a succinct answer. 9.45e+07. What is the difference between the highest and the lowest Amount (in current US$) in Bolivia?
Offer a very short reply. 6.98e+08. What is the difference between the highest and the lowest Amount (in current US$) of Mexico?
Offer a terse response. 5.75e+1. What is the difference between the highest and the lowest Amount (in current US$) of Nicaragua?
Provide a short and direct response. 7.17e+08. 